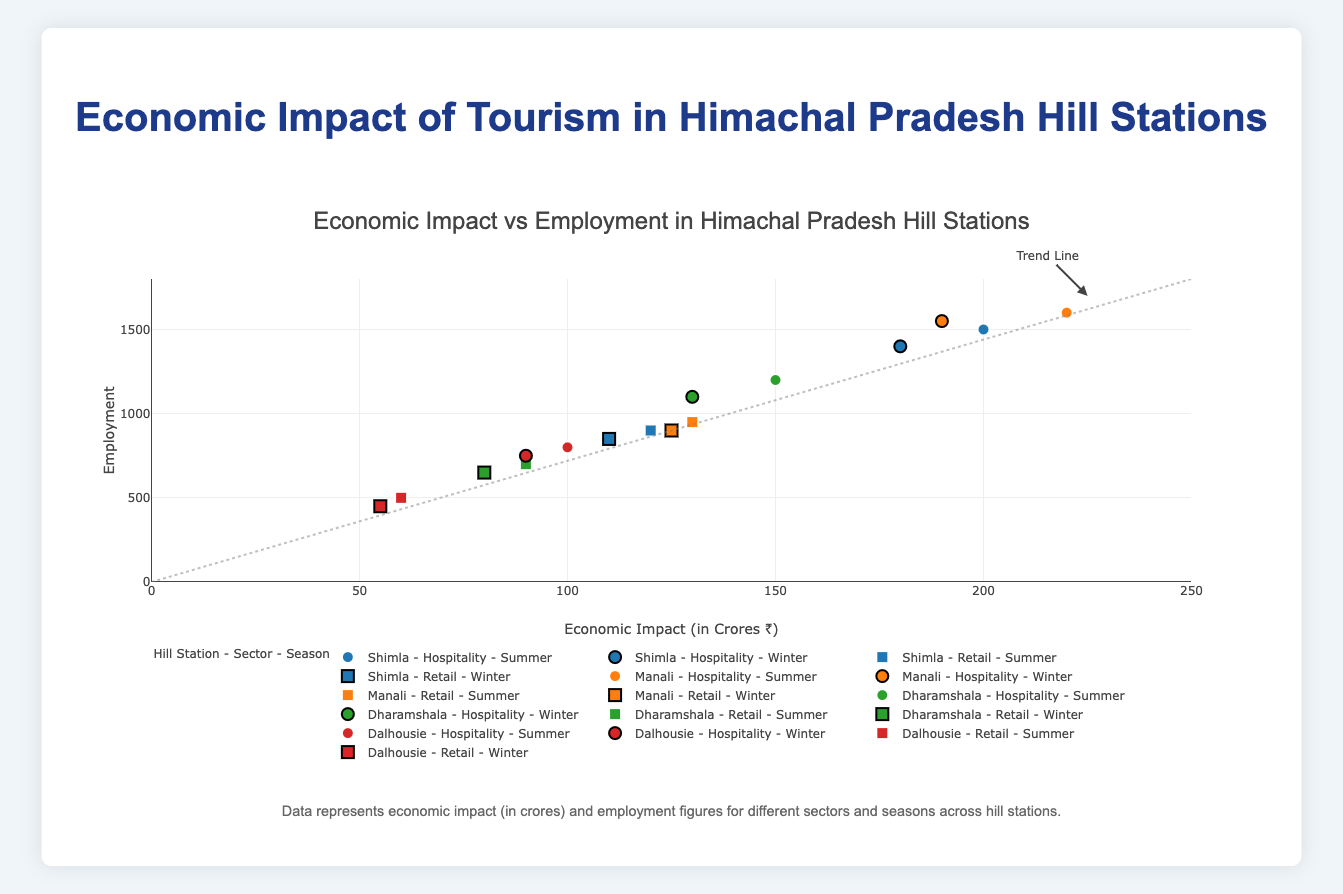What is the title of the plot? The title of the plot is displayed at the top of the figure. It helps to understand the overall topic of the visualization.
Answer: Economic Impact vs Employment in Himachal Pradesh Hill Stations Which hill station has the highest economic impact in the hospitality sector during the summer season? Look for the data points that have the highest x-values (economic impact) in the hospitality sector (represented by circles) for all hill stations during the summer (white outline).
Answer: Manali In which hill station and season is the employment lowest in the retail sector? Identify the data points with the lowest y-values (employment) within the retail sector (represented by squares) across all hill stations and seasons.
Answer: Dalhousie (Winter) How does the economic impact in Shimla's retail sector compare between summer and winter? Compare the x-values (economic impact) for Shimla's retail sector during summer and winter.
Answer: Summer: ₹120 Cr, Winter: ₹110 Cr What is the overall trend shown by the line in the plot? The line represents a trend indicating the relationship between economic impact and employment.
Answer: Positive correlation Which hill station and season have the highest employment in the hospitality sector? Look for the data point with the highest y-value (employment) within the hospitality sector (represented by circles) across all seasons and hill stations.
Answer: Manali (Summer) What is the economic impact of the hospitality sector in Dalhousie during winter? Identify the data point for Dalhousie in the hospitality sector during winter and check its x-value.
Answer: ₹90 Cr Compare the employment in the retail sector of Dharamshala during summer and winter seasons. Compare the y-values (employment) for the retail sector in Dharamshala between summer and winter.
Answer: Summer: 700, Winter: 650 Which sector, among hospitality and retail, shows a higher economic impact in Manali during the summer? Compare the x-values (economic impact) for both sectors in Manali during the summer.
Answer: Hospitality: ₹220 Cr Is there any hill station where the winter season has a higher economic impact than the summer season for the same sector? Compare the economic impact in pairs of data points for the same sector within the same hill station for both summer and winter seasons.
Answer: No 